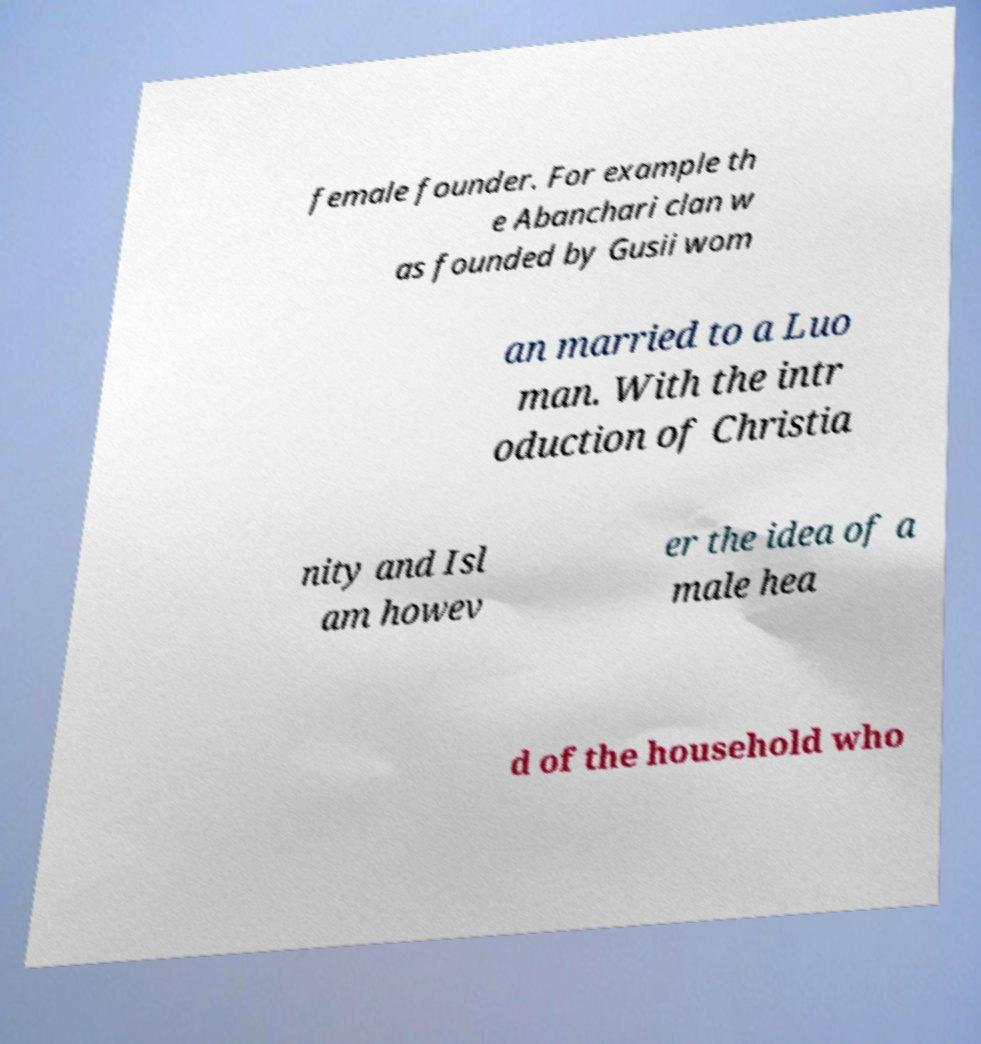Please identify and transcribe the text found in this image. female founder. For example th e Abanchari clan w as founded by Gusii wom an married to a Luo man. With the intr oduction of Christia nity and Isl am howev er the idea of a male hea d of the household who 